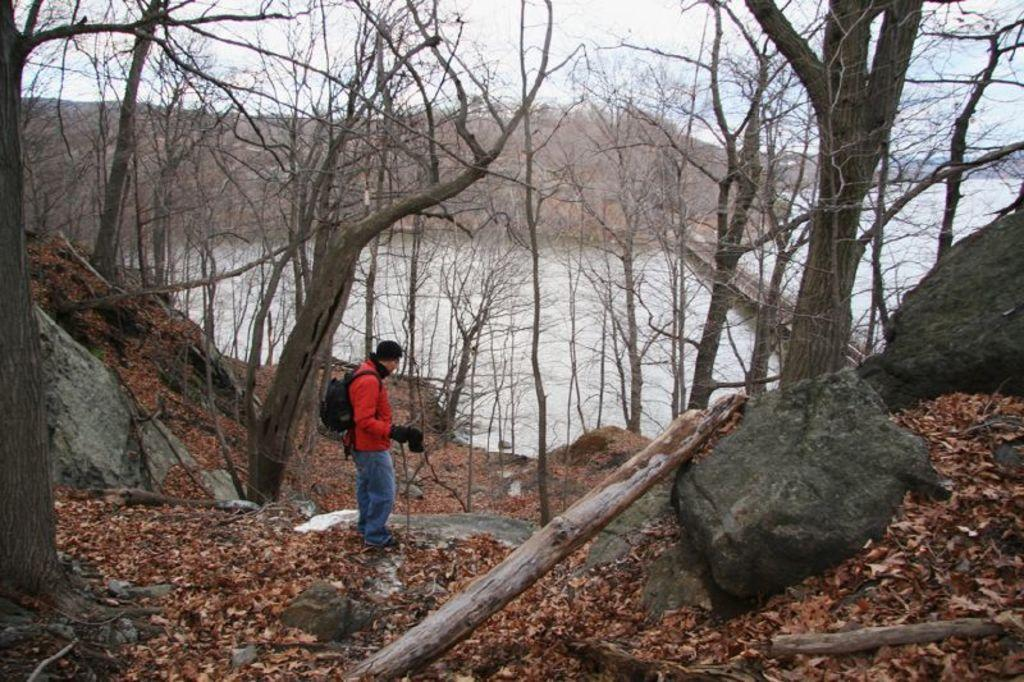What can be seen in the image? There is a person in the image. What is the person wearing? The person is wearing an orange jacket. What is the person doing in the image? The person is standing. What is the person carrying on their back? The person is carrying a bag on their back. What can be seen in the background of the image? There are dried trees and water visible in the background of the image. How many babies are visible in the image? There are no babies present in the image. What type of bushes can be seen in the image? There are no bushes present in the image. 